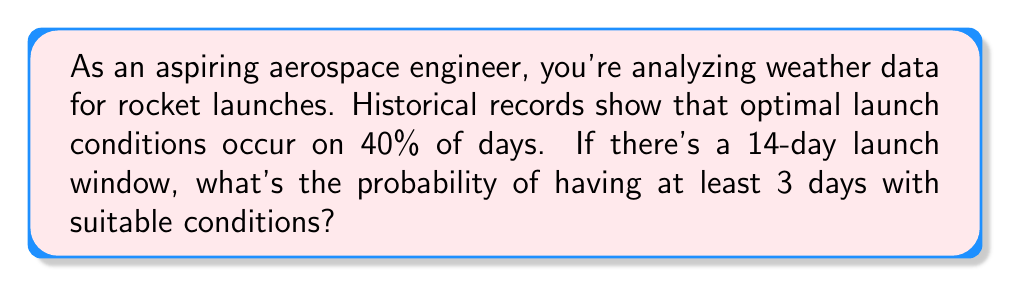Teach me how to tackle this problem. Let's approach this step-by-step:

1) This is a binomial probability problem. We need to find P(X ≥ 3), where X is the number of days with suitable conditions.

2) We know:
   n (number of trials) = 14 days
   p (probability of success on each trial) = 0.40
   q (probability of failure on each trial) = 1 - p = 0.60

3) The probability of having exactly k successes in n trials is given by the binomial probability formula:

   $$ P(X = k) = \binom{n}{k} p^k q^{n-k} $$

4) We need to sum this for k = 3, 4, ..., 14:

   $$ P(X \geq 3) = \sum_{k=3}^{14} \binom{14}{k} (0.40)^k (0.60)^{14-k} $$

5) Using a calculator or computer (as this would be tedious to calculate by hand):

   $$ P(X \geq 3) = 1 - [P(X = 0) + P(X = 1) + P(X = 2)] $$
   $$ = 1 - [\binom{14}{0}(0.40)^0(0.60)^{14} + \binom{14}{1}(0.40)^1(0.60)^{13} + \binom{14}{2}(0.40)^2(0.60)^{12}] $$
   $$ ≈ 1 - [0.0001 + 0.0013 + 0.0087] $$
   $$ ≈ 1 - 0.0101 $$
   $$ ≈ 0.9899 $$

6) Therefore, the probability of having at least 3 days with suitable conditions is approximately 0.9899 or 98.99%.
Answer: 0.9899 